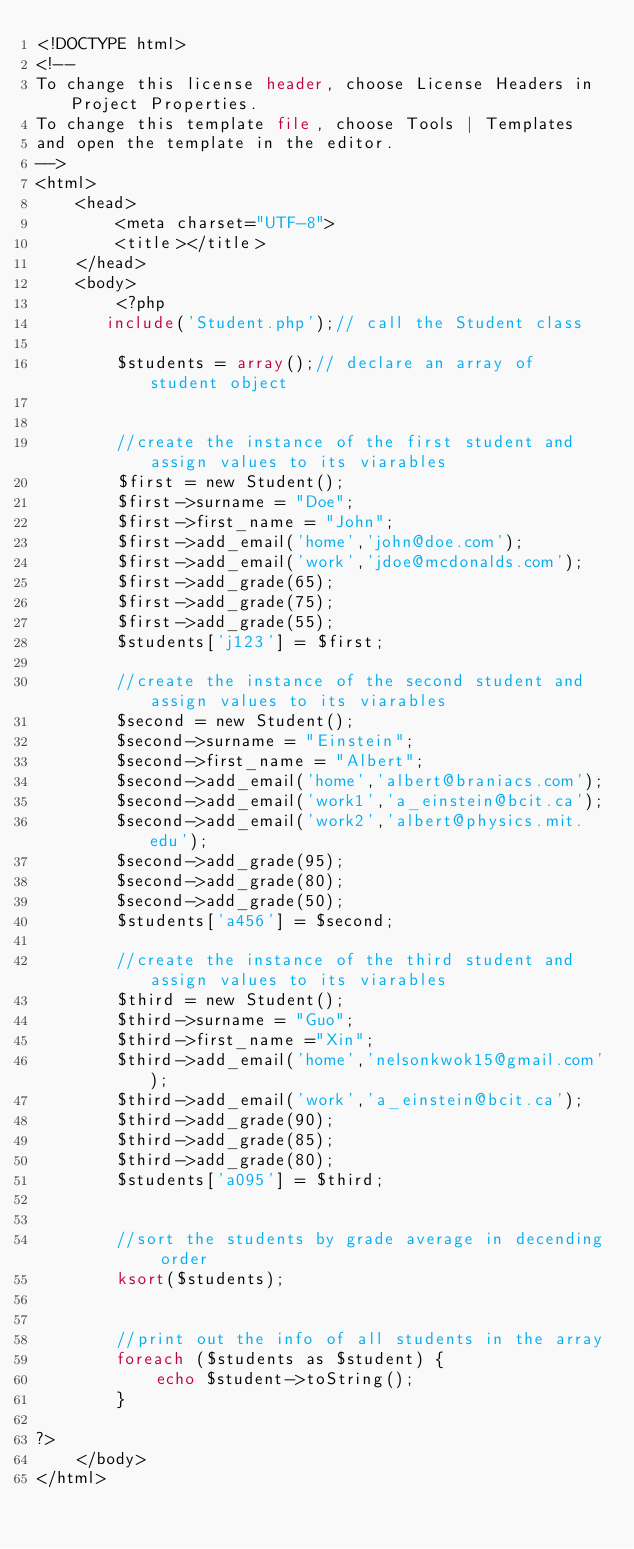<code> <loc_0><loc_0><loc_500><loc_500><_PHP_><!DOCTYPE html>
<!--
To change this license header, choose License Headers in Project Properties.
To change this template file, choose Tools | Templates
and open the template in the editor.
-->
<html>
    <head>
        <meta charset="UTF-8">
        <title></title>
    </head>
    <body>
        <?php
       include('Student.php');// call the Student class

        $students = array();// declare an array of student object 

        
        //create the instance of the first student and assign values to its viarables
        $first = new Student();
        $first->surname = "Doe";
        $first->first_name = "John";
        $first->add_email('home','john@doe.com');
        $first->add_email('work','jdoe@mcdonalds.com');
        $first->add_grade(65);
        $first->add_grade(75);
        $first->add_grade(55);
        $students['j123'] = $first;
        
        //create the instance of the second student and assign values to its viarables
        $second = new Student();
        $second->surname = "Einstein";
        $second->first_name = "Albert";
        $second->add_email('home','albert@braniacs.com');
        $second->add_email('work1','a_einstein@bcit.ca');
        $second->add_email('work2','albert@physics.mit.edu');
        $second->add_grade(95);
        $second->add_grade(80);
        $second->add_grade(50);
        $students['a456'] = $second;
        
        //create the instance of the third student and assign values to its viarables
        $third = new Student();
        $third->surname = "Guo";
        $third->first_name ="Xin";
        $third->add_email('home','nelsonkwok15@gmail.com');
        $third->add_email('work','a_einstein@bcit.ca');
        $third->add_grade(90);
        $third->add_grade(85);
        $third->add_grade(80);
        $students['a095'] = $third;
        
        
        //sort the students by grade average in decending order 
        ksort($students);

        
        //print out the info of all students in the array
        foreach ($students as $student) {
            echo $student->toString();
        }
        
?>
    </body>
</html>
</code> 